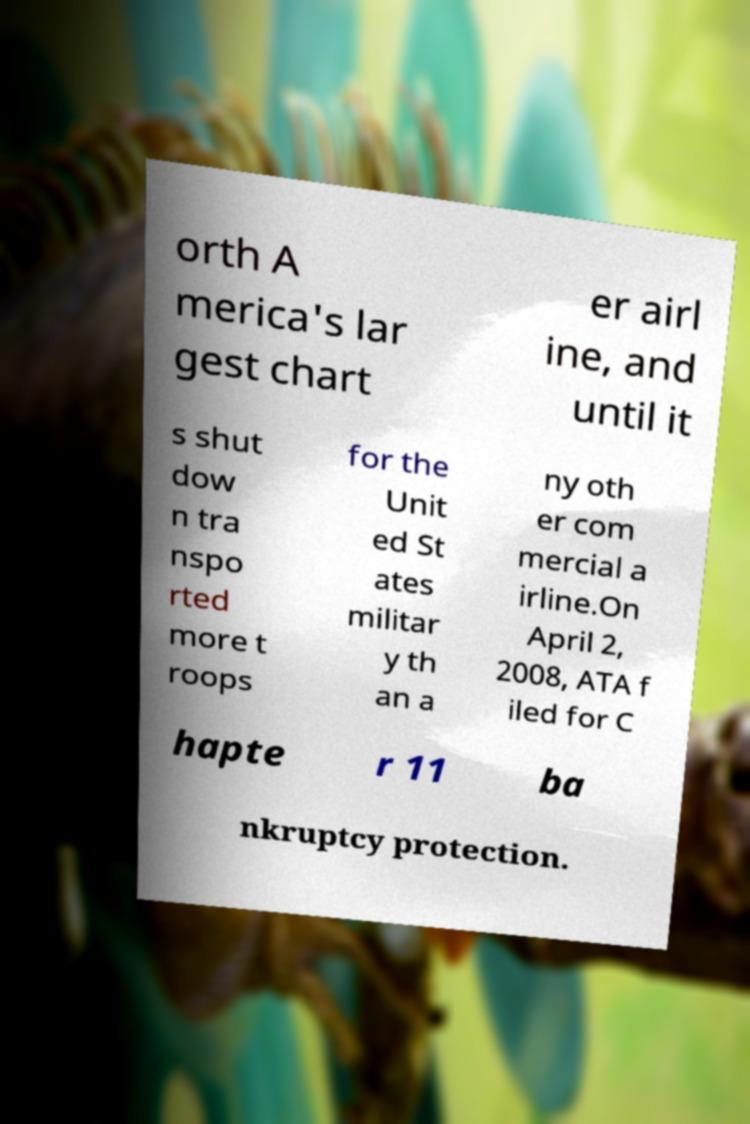There's text embedded in this image that I need extracted. Can you transcribe it verbatim? orth A merica's lar gest chart er airl ine, and until it s shut dow n tra nspo rted more t roops for the Unit ed St ates militar y th an a ny oth er com mercial a irline.On April 2, 2008, ATA f iled for C hapte r 11 ba nkruptcy protection. 